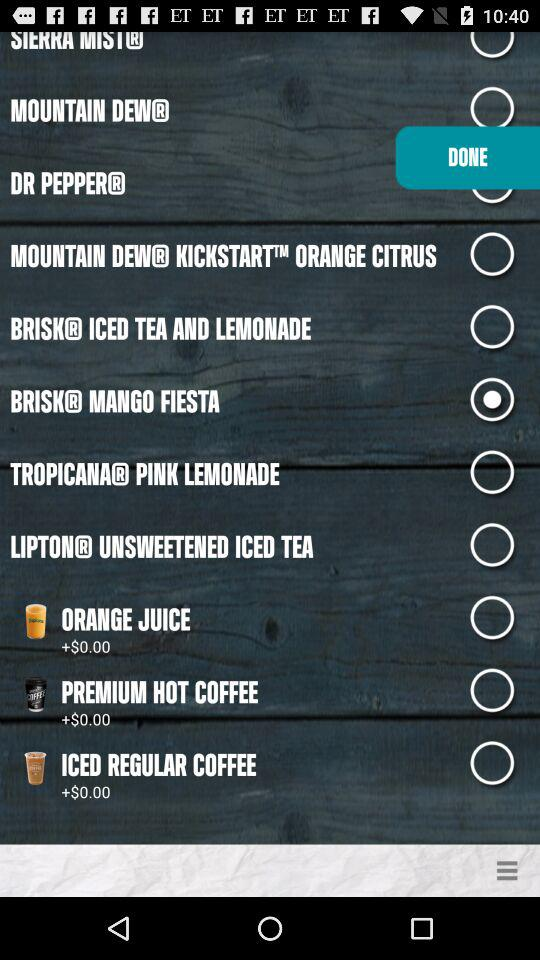Which drink is selected? The selected drink is Brisk Mango Fiesta. 